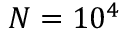<formula> <loc_0><loc_0><loc_500><loc_500>N = 1 0 ^ { 4 }</formula> 